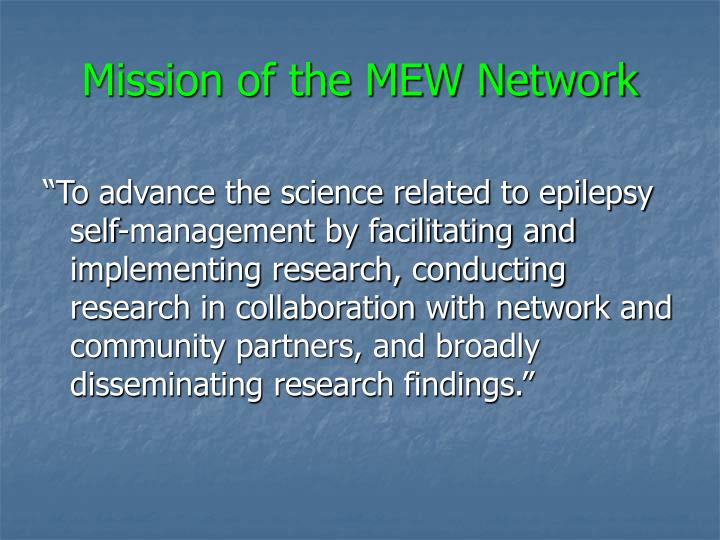What are some examples of community partnerships that might be involved with the MEW Network? Community partnerships for the MEW Network could include collaborations with healthcare providers, educational institutions, epilepsy advocacy groups, and other research organizations. Such partnerships help in creating a holistic research environment that not only focuses on the medical aspects of epilepsy but also on educational, social, and emotional support systems for those affected. 